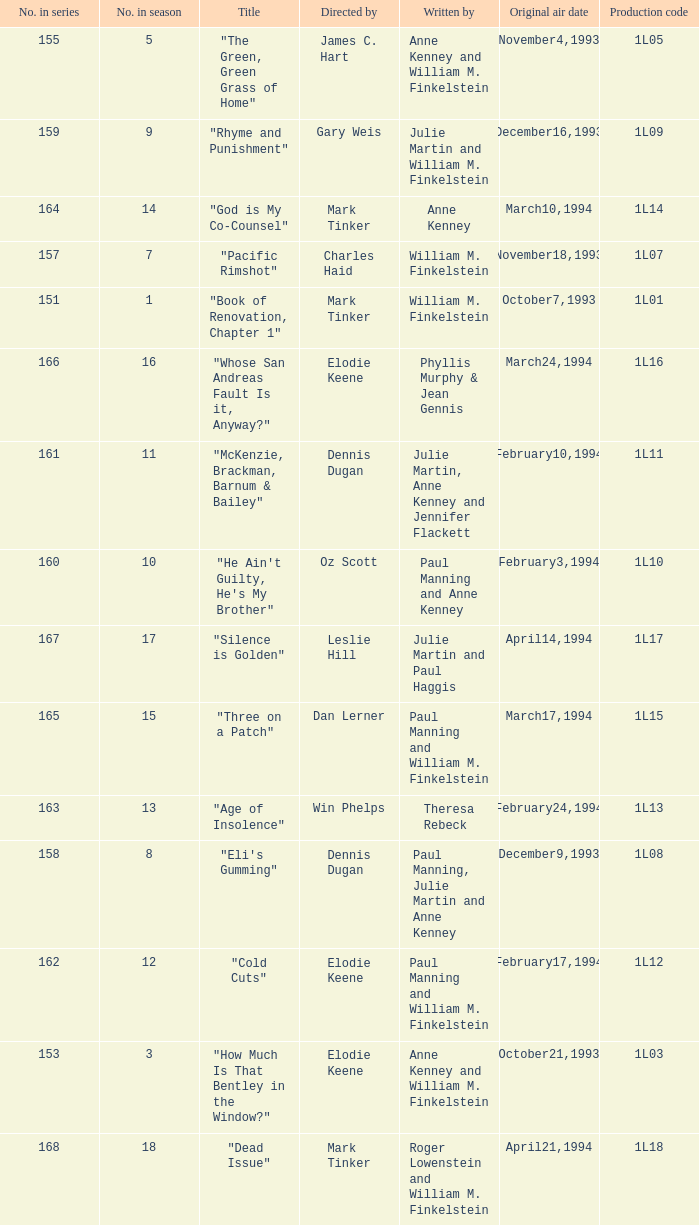Name the original air date for production code 1l16 March24,1994. 